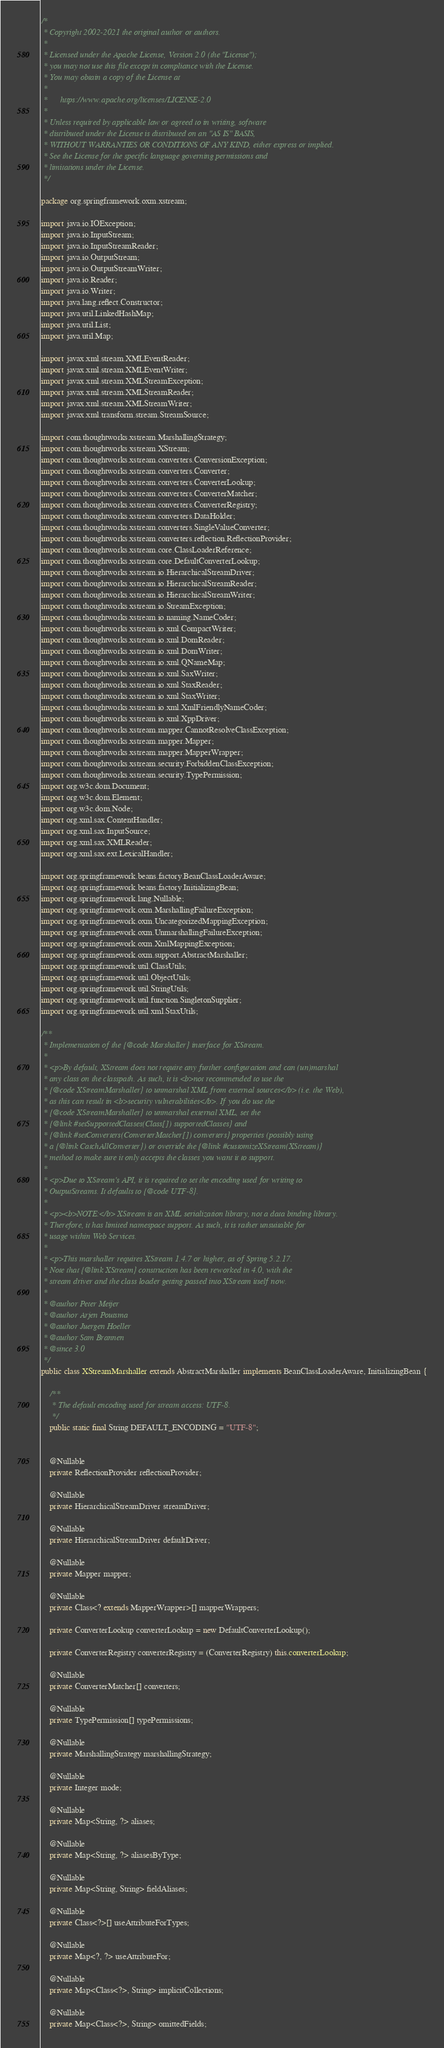Convert code to text. <code><loc_0><loc_0><loc_500><loc_500><_Java_>/*
 * Copyright 2002-2021 the original author or authors.
 *
 * Licensed under the Apache License, Version 2.0 (the "License");
 * you may not use this file except in compliance with the License.
 * You may obtain a copy of the License at
 *
 *      https://www.apache.org/licenses/LICENSE-2.0
 *
 * Unless required by applicable law or agreed to in writing, software
 * distributed under the License is distributed on an "AS IS" BASIS,
 * WITHOUT WARRANTIES OR CONDITIONS OF ANY KIND, either express or implied.
 * See the License for the specific language governing permissions and
 * limitations under the License.
 */

package org.springframework.oxm.xstream;

import java.io.IOException;
import java.io.InputStream;
import java.io.InputStreamReader;
import java.io.OutputStream;
import java.io.OutputStreamWriter;
import java.io.Reader;
import java.io.Writer;
import java.lang.reflect.Constructor;
import java.util.LinkedHashMap;
import java.util.List;
import java.util.Map;

import javax.xml.stream.XMLEventReader;
import javax.xml.stream.XMLEventWriter;
import javax.xml.stream.XMLStreamException;
import javax.xml.stream.XMLStreamReader;
import javax.xml.stream.XMLStreamWriter;
import javax.xml.transform.stream.StreamSource;

import com.thoughtworks.xstream.MarshallingStrategy;
import com.thoughtworks.xstream.XStream;
import com.thoughtworks.xstream.converters.ConversionException;
import com.thoughtworks.xstream.converters.Converter;
import com.thoughtworks.xstream.converters.ConverterLookup;
import com.thoughtworks.xstream.converters.ConverterMatcher;
import com.thoughtworks.xstream.converters.ConverterRegistry;
import com.thoughtworks.xstream.converters.DataHolder;
import com.thoughtworks.xstream.converters.SingleValueConverter;
import com.thoughtworks.xstream.converters.reflection.ReflectionProvider;
import com.thoughtworks.xstream.core.ClassLoaderReference;
import com.thoughtworks.xstream.core.DefaultConverterLookup;
import com.thoughtworks.xstream.io.HierarchicalStreamDriver;
import com.thoughtworks.xstream.io.HierarchicalStreamReader;
import com.thoughtworks.xstream.io.HierarchicalStreamWriter;
import com.thoughtworks.xstream.io.StreamException;
import com.thoughtworks.xstream.io.naming.NameCoder;
import com.thoughtworks.xstream.io.xml.CompactWriter;
import com.thoughtworks.xstream.io.xml.DomReader;
import com.thoughtworks.xstream.io.xml.DomWriter;
import com.thoughtworks.xstream.io.xml.QNameMap;
import com.thoughtworks.xstream.io.xml.SaxWriter;
import com.thoughtworks.xstream.io.xml.StaxReader;
import com.thoughtworks.xstream.io.xml.StaxWriter;
import com.thoughtworks.xstream.io.xml.XmlFriendlyNameCoder;
import com.thoughtworks.xstream.io.xml.XppDriver;
import com.thoughtworks.xstream.mapper.CannotResolveClassException;
import com.thoughtworks.xstream.mapper.Mapper;
import com.thoughtworks.xstream.mapper.MapperWrapper;
import com.thoughtworks.xstream.security.ForbiddenClassException;
import com.thoughtworks.xstream.security.TypePermission;
import org.w3c.dom.Document;
import org.w3c.dom.Element;
import org.w3c.dom.Node;
import org.xml.sax.ContentHandler;
import org.xml.sax.InputSource;
import org.xml.sax.XMLReader;
import org.xml.sax.ext.LexicalHandler;

import org.springframework.beans.factory.BeanClassLoaderAware;
import org.springframework.beans.factory.InitializingBean;
import org.springframework.lang.Nullable;
import org.springframework.oxm.MarshallingFailureException;
import org.springframework.oxm.UncategorizedMappingException;
import org.springframework.oxm.UnmarshallingFailureException;
import org.springframework.oxm.XmlMappingException;
import org.springframework.oxm.support.AbstractMarshaller;
import org.springframework.util.ClassUtils;
import org.springframework.util.ObjectUtils;
import org.springframework.util.StringUtils;
import org.springframework.util.function.SingletonSupplier;
import org.springframework.util.xml.StaxUtils;

/**
 * Implementation of the {@code Marshaller} interface for XStream.
 *
 * <p>By default, XStream does not require any further configuration and can (un)marshal
 * any class on the classpath. As such, it is <b>not recommended to use the
 * {@code XStreamMarshaller} to unmarshal XML from external sources</b> (i.e. the Web),
 * as this can result in <b>security vulnerabilities</b>. If you do use the
 * {@code XStreamMarshaller} to unmarshal external XML, set the
 * {@link #setSupportedClasses(Class[]) supportedClasses} and
 * {@link #setConverters(ConverterMatcher[]) converters} properties (possibly using
 * a {@link CatchAllConverter}) or override the {@link #customizeXStream(XStream)}
 * method to make sure it only accepts the classes you want it to support.
 *
 * <p>Due to XStream's API, it is required to set the encoding used for writing to
 * OutputStreams. It defaults to {@code UTF-8}.
 *
 * <p><b>NOTE:</b> XStream is an XML serialization library, not a data binding library.
 * Therefore, it has limited namespace support. As such, it is rather unsuitable for
 * usage within Web Services.
 *
 * <p>This marshaller requires XStream 1.4.7 or higher, as of Spring 5.2.17.
 * Note that {@link XStream} construction has been reworked in 4.0, with the
 * stream driver and the class loader getting passed into XStream itself now.
 *
 * @author Peter Meijer
 * @author Arjen Poutsma
 * @author Juergen Hoeller
 * @author Sam Brannen
 * @since 3.0
 */
public class XStreamMarshaller extends AbstractMarshaller implements BeanClassLoaderAware, InitializingBean {

	/**
	 * The default encoding used for stream access: UTF-8.
	 */
	public static final String DEFAULT_ENCODING = "UTF-8";


	@Nullable
	private ReflectionProvider reflectionProvider;

	@Nullable
	private HierarchicalStreamDriver streamDriver;

	@Nullable
	private HierarchicalStreamDriver defaultDriver;

	@Nullable
	private Mapper mapper;

	@Nullable
	private Class<? extends MapperWrapper>[] mapperWrappers;

	private ConverterLookup converterLookup = new DefaultConverterLookup();

	private ConverterRegistry converterRegistry = (ConverterRegistry) this.converterLookup;

	@Nullable
	private ConverterMatcher[] converters;

	@Nullable
	private TypePermission[] typePermissions;

	@Nullable
	private MarshallingStrategy marshallingStrategy;

	@Nullable
	private Integer mode;

	@Nullable
	private Map<String, ?> aliases;

	@Nullable
	private Map<String, ?> aliasesByType;

	@Nullable
	private Map<String, String> fieldAliases;

	@Nullable
	private Class<?>[] useAttributeForTypes;

	@Nullable
	private Map<?, ?> useAttributeFor;

	@Nullable
	private Map<Class<?>, String> implicitCollections;

	@Nullable
	private Map<Class<?>, String> omittedFields;
</code> 